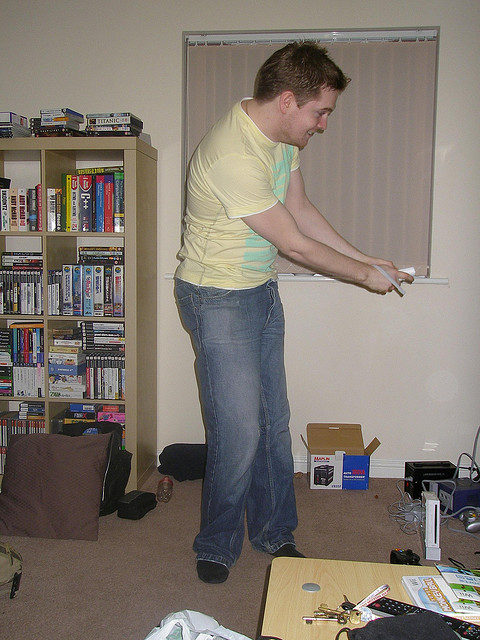<image>What is the child's name? It is unknown what the child's name is. What is the child's name? I don't know the child's name. It can be Bill, Dan, Fred, Henry, Jeff, Mike, John or unknown. 